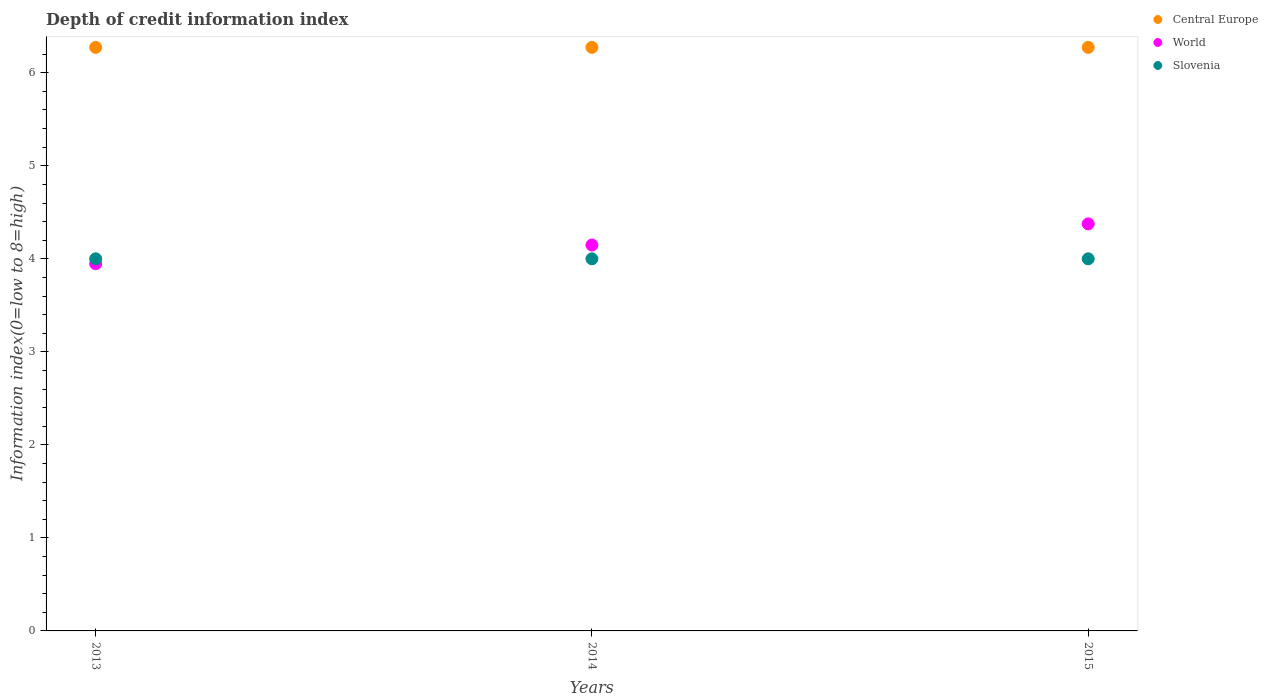How many different coloured dotlines are there?
Ensure brevity in your answer.  3. Is the number of dotlines equal to the number of legend labels?
Your response must be concise. Yes. What is the information index in Central Europe in 2013?
Ensure brevity in your answer.  6.27. Across all years, what is the maximum information index in Slovenia?
Provide a succinct answer. 4. Across all years, what is the minimum information index in Slovenia?
Ensure brevity in your answer.  4. In which year was the information index in Slovenia maximum?
Offer a very short reply. 2013. In which year was the information index in World minimum?
Ensure brevity in your answer.  2013. What is the total information index in Central Europe in the graph?
Provide a short and direct response. 18.82. What is the difference between the information index in World in 2013 and that in 2015?
Provide a succinct answer. -0.43. What is the difference between the information index in World in 2013 and the information index in Central Europe in 2014?
Your answer should be very brief. -2.33. What is the average information index in World per year?
Your answer should be compact. 4.16. In the year 2015, what is the difference between the information index in World and information index in Central Europe?
Make the answer very short. -1.9. In how many years, is the information index in World greater than 2.8?
Your answer should be very brief. 3. What is the ratio of the information index in Slovenia in 2013 to that in 2014?
Offer a terse response. 1. Is the difference between the information index in World in 2013 and 2015 greater than the difference between the information index in Central Europe in 2013 and 2015?
Provide a succinct answer. No. What is the difference between the highest and the lowest information index in Slovenia?
Your response must be concise. 0. Does the information index in Central Europe monotonically increase over the years?
Ensure brevity in your answer.  No. Is the information index in Slovenia strictly greater than the information index in World over the years?
Provide a short and direct response. No. How many dotlines are there?
Give a very brief answer. 3. What is the difference between two consecutive major ticks on the Y-axis?
Your answer should be very brief. 1. Are the values on the major ticks of Y-axis written in scientific E-notation?
Your answer should be compact. No. Does the graph contain grids?
Ensure brevity in your answer.  No. Where does the legend appear in the graph?
Provide a short and direct response. Top right. How many legend labels are there?
Your response must be concise. 3. What is the title of the graph?
Your response must be concise. Depth of credit information index. What is the label or title of the X-axis?
Your answer should be very brief. Years. What is the label or title of the Y-axis?
Your answer should be compact. Information index(0=low to 8=high). What is the Information index(0=low to 8=high) of Central Europe in 2013?
Give a very brief answer. 6.27. What is the Information index(0=low to 8=high) in World in 2013?
Your response must be concise. 3.95. What is the Information index(0=low to 8=high) in Slovenia in 2013?
Your answer should be compact. 4. What is the Information index(0=low to 8=high) of Central Europe in 2014?
Provide a succinct answer. 6.27. What is the Information index(0=low to 8=high) of World in 2014?
Offer a terse response. 4.15. What is the Information index(0=low to 8=high) in Slovenia in 2014?
Give a very brief answer. 4. What is the Information index(0=low to 8=high) of Central Europe in 2015?
Keep it short and to the point. 6.27. What is the Information index(0=low to 8=high) of World in 2015?
Keep it short and to the point. 4.38. What is the Information index(0=low to 8=high) of Slovenia in 2015?
Ensure brevity in your answer.  4. Across all years, what is the maximum Information index(0=low to 8=high) in Central Europe?
Give a very brief answer. 6.27. Across all years, what is the maximum Information index(0=low to 8=high) of World?
Offer a very short reply. 4.38. Across all years, what is the maximum Information index(0=low to 8=high) of Slovenia?
Ensure brevity in your answer.  4. Across all years, what is the minimum Information index(0=low to 8=high) of Central Europe?
Your answer should be compact. 6.27. Across all years, what is the minimum Information index(0=low to 8=high) in World?
Your answer should be very brief. 3.95. What is the total Information index(0=low to 8=high) of Central Europe in the graph?
Make the answer very short. 18.82. What is the total Information index(0=low to 8=high) of World in the graph?
Ensure brevity in your answer.  12.47. What is the difference between the Information index(0=low to 8=high) of Central Europe in 2013 and that in 2014?
Your response must be concise. 0. What is the difference between the Information index(0=low to 8=high) in World in 2013 and that in 2014?
Provide a short and direct response. -0.2. What is the difference between the Information index(0=low to 8=high) of Slovenia in 2013 and that in 2014?
Give a very brief answer. 0. What is the difference between the Information index(0=low to 8=high) of World in 2013 and that in 2015?
Make the answer very short. -0.43. What is the difference between the Information index(0=low to 8=high) in Slovenia in 2013 and that in 2015?
Give a very brief answer. 0. What is the difference between the Information index(0=low to 8=high) in World in 2014 and that in 2015?
Your answer should be very brief. -0.23. What is the difference between the Information index(0=low to 8=high) of Slovenia in 2014 and that in 2015?
Your answer should be compact. 0. What is the difference between the Information index(0=low to 8=high) in Central Europe in 2013 and the Information index(0=low to 8=high) in World in 2014?
Provide a succinct answer. 2.12. What is the difference between the Information index(0=low to 8=high) of Central Europe in 2013 and the Information index(0=low to 8=high) of Slovenia in 2014?
Provide a short and direct response. 2.27. What is the difference between the Information index(0=low to 8=high) in World in 2013 and the Information index(0=low to 8=high) in Slovenia in 2014?
Your answer should be very brief. -0.05. What is the difference between the Information index(0=low to 8=high) of Central Europe in 2013 and the Information index(0=low to 8=high) of World in 2015?
Your answer should be compact. 1.9. What is the difference between the Information index(0=low to 8=high) of Central Europe in 2013 and the Information index(0=low to 8=high) of Slovenia in 2015?
Keep it short and to the point. 2.27. What is the difference between the Information index(0=low to 8=high) of World in 2013 and the Information index(0=low to 8=high) of Slovenia in 2015?
Give a very brief answer. -0.05. What is the difference between the Information index(0=low to 8=high) in Central Europe in 2014 and the Information index(0=low to 8=high) in World in 2015?
Offer a very short reply. 1.9. What is the difference between the Information index(0=low to 8=high) of Central Europe in 2014 and the Information index(0=low to 8=high) of Slovenia in 2015?
Provide a succinct answer. 2.27. What is the difference between the Information index(0=low to 8=high) in World in 2014 and the Information index(0=low to 8=high) in Slovenia in 2015?
Your response must be concise. 0.15. What is the average Information index(0=low to 8=high) in Central Europe per year?
Ensure brevity in your answer.  6.27. What is the average Information index(0=low to 8=high) in World per year?
Offer a terse response. 4.16. What is the average Information index(0=low to 8=high) in Slovenia per year?
Your answer should be compact. 4. In the year 2013, what is the difference between the Information index(0=low to 8=high) of Central Europe and Information index(0=low to 8=high) of World?
Give a very brief answer. 2.33. In the year 2013, what is the difference between the Information index(0=low to 8=high) in Central Europe and Information index(0=low to 8=high) in Slovenia?
Keep it short and to the point. 2.27. In the year 2013, what is the difference between the Information index(0=low to 8=high) in World and Information index(0=low to 8=high) in Slovenia?
Offer a very short reply. -0.05. In the year 2014, what is the difference between the Information index(0=low to 8=high) in Central Europe and Information index(0=low to 8=high) in World?
Make the answer very short. 2.12. In the year 2014, what is the difference between the Information index(0=low to 8=high) of Central Europe and Information index(0=low to 8=high) of Slovenia?
Your answer should be very brief. 2.27. In the year 2014, what is the difference between the Information index(0=low to 8=high) of World and Information index(0=low to 8=high) of Slovenia?
Give a very brief answer. 0.15. In the year 2015, what is the difference between the Information index(0=low to 8=high) of Central Europe and Information index(0=low to 8=high) of World?
Provide a short and direct response. 1.9. In the year 2015, what is the difference between the Information index(0=low to 8=high) in Central Europe and Information index(0=low to 8=high) in Slovenia?
Make the answer very short. 2.27. In the year 2015, what is the difference between the Information index(0=low to 8=high) in World and Information index(0=low to 8=high) in Slovenia?
Provide a short and direct response. 0.38. What is the ratio of the Information index(0=low to 8=high) in World in 2013 to that in 2014?
Provide a short and direct response. 0.95. What is the ratio of the Information index(0=low to 8=high) of Central Europe in 2013 to that in 2015?
Your answer should be compact. 1. What is the ratio of the Information index(0=low to 8=high) in World in 2013 to that in 2015?
Give a very brief answer. 0.9. What is the ratio of the Information index(0=low to 8=high) in Slovenia in 2013 to that in 2015?
Your answer should be compact. 1. What is the ratio of the Information index(0=low to 8=high) of World in 2014 to that in 2015?
Give a very brief answer. 0.95. What is the difference between the highest and the second highest Information index(0=low to 8=high) of World?
Provide a short and direct response. 0.23. What is the difference between the highest and the lowest Information index(0=low to 8=high) in World?
Your response must be concise. 0.43. 